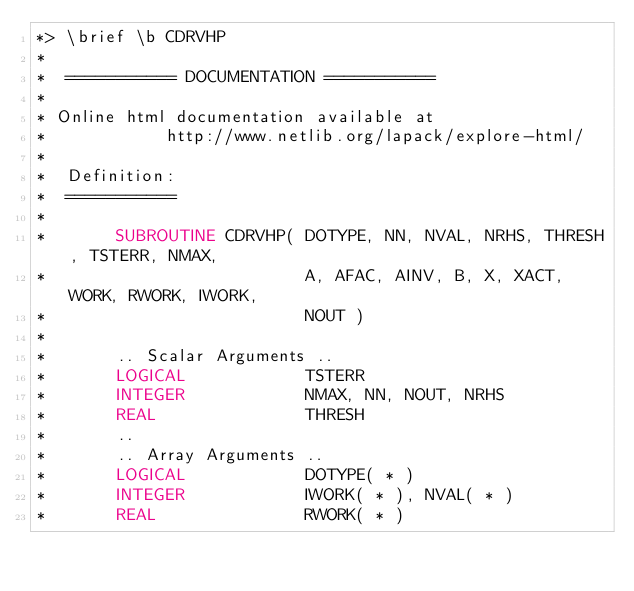Convert code to text. <code><loc_0><loc_0><loc_500><loc_500><_FORTRAN_>*> \brief \b CDRVHP
*
*  =========== DOCUMENTATION ===========
*
* Online html documentation available at
*            http://www.netlib.org/lapack/explore-html/
*
*  Definition:
*  ===========
*
*       SUBROUTINE CDRVHP( DOTYPE, NN, NVAL, NRHS, THRESH, TSTERR, NMAX,
*                          A, AFAC, AINV, B, X, XACT, WORK, RWORK, IWORK,
*                          NOUT )
*
*       .. Scalar Arguments ..
*       LOGICAL            TSTERR
*       INTEGER            NMAX, NN, NOUT, NRHS
*       REAL               THRESH
*       ..
*       .. Array Arguments ..
*       LOGICAL            DOTYPE( * )
*       INTEGER            IWORK( * ), NVAL( * )
*       REAL               RWORK( * )</code> 